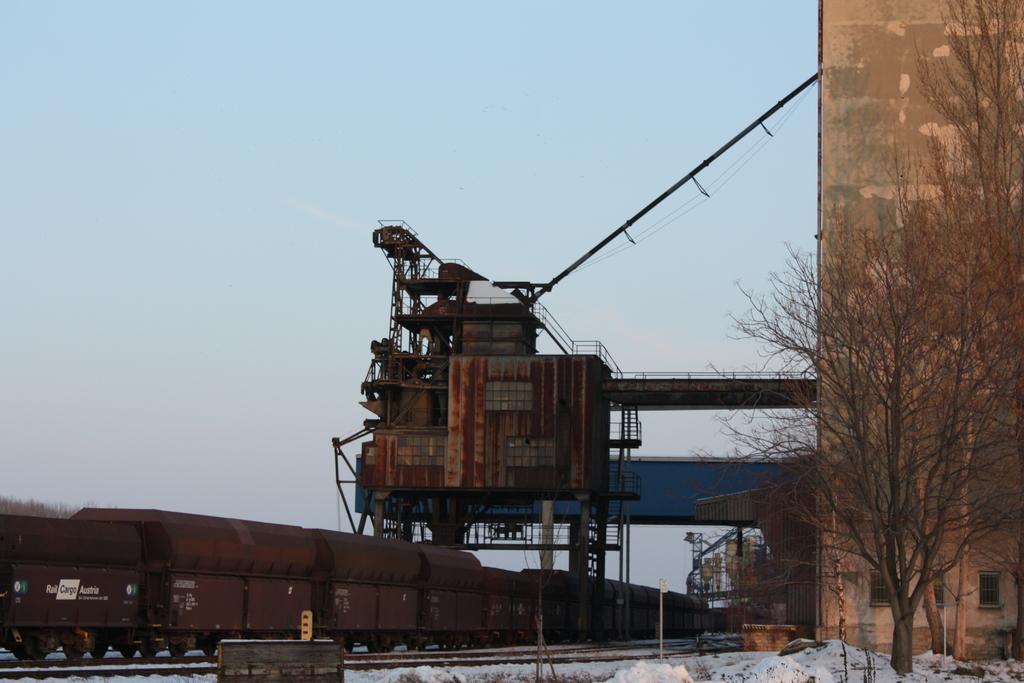Please provide a concise description of this image. In the foreground of this image, there is a train on the track which is on the left side. We can also see few poles, trees and the snow at the bottom. In the middle, there is an industry. At the top, there is the sky. 